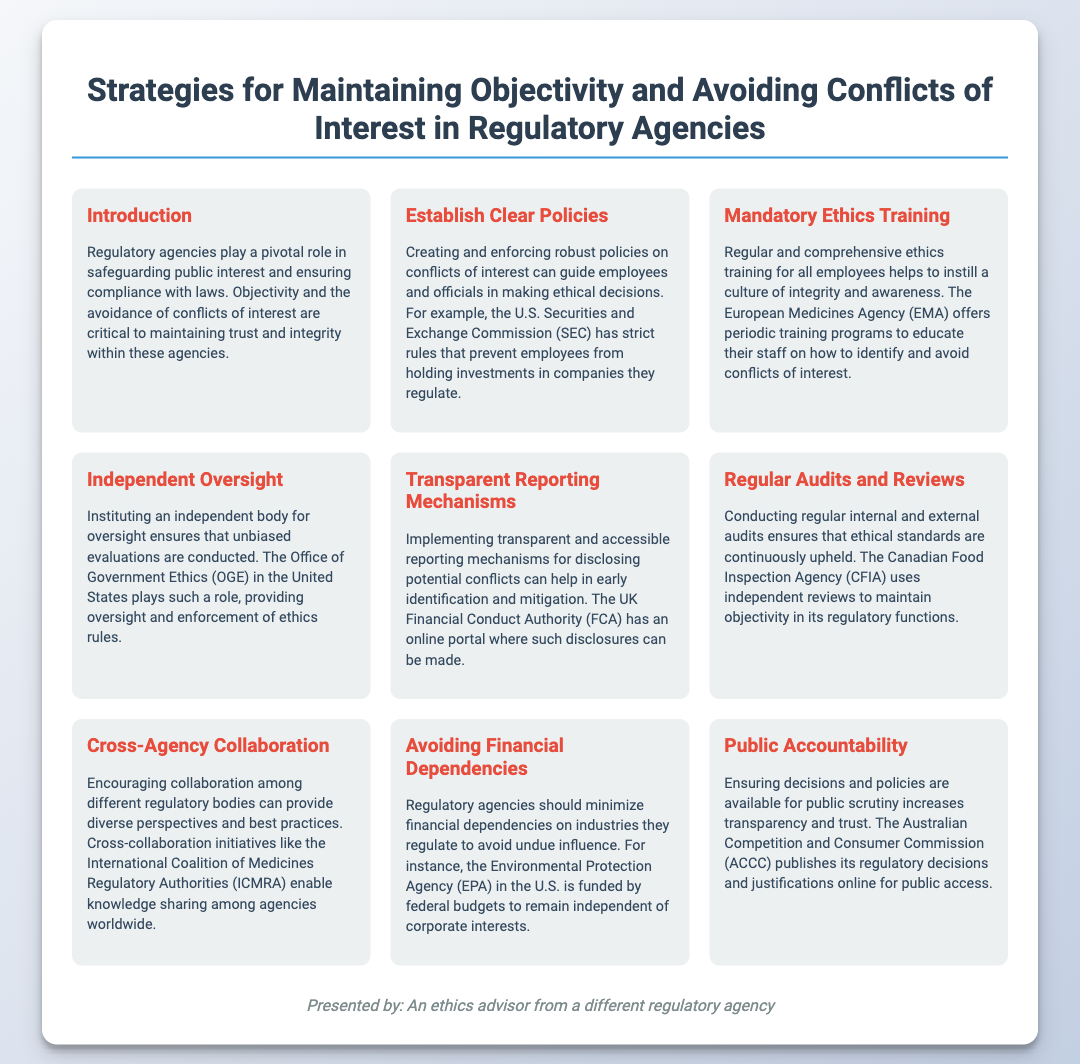What is the main focus of regulatory agencies? The main focus of regulatory agencies is safeguarding public interest and ensuring compliance with laws.
Answer: safeguarding public interest What example of an organization is mentioned for establishing clear policies? The document mentions the U.S. Securities and Exchange Commission as an example organization for establishing clear policies.
Answer: U.S. Securities and Exchange Commission What kind of training is emphasized for employees? Regular and comprehensive ethics training is emphasized for employees.
Answer: ethics training Who provides oversight for ethics rules in the United States? The Office of Government Ethics in the United States provides oversight for ethics rules.
Answer: Office of Government Ethics How does the UK Financial Conduct Authority support conflict disclosure? The UK Financial Conduct Authority provides an online portal for disclosing potential conflicts.
Answer: online portal What is one strategy to enhance transparency? Ensuring decisions and policies are available for public scrutiny enhances transparency.
Answer: public scrutiny Which agency is cited as avoiding financial dependencies? The Environmental Protection Agency is cited as avoiding financial dependencies on industries they regulate.
Answer: Environmental Protection Agency What initiative encourages collaboration among regulatory bodies? The International Coalition of Medicines Regulatory Authorities (ICMRA) encourages collaboration among regulatory bodies.
Answer: International Coalition of Medicines Regulatory Authorities What is a benefit of conducting regular audits? Regular audits ensure that ethical standards are continuously upheld.
Answer: continuous upholding of ethical standards 